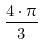Convert formula to latex. <formula><loc_0><loc_0><loc_500><loc_500>\frac { 4 \cdot \pi } { 3 }</formula> 